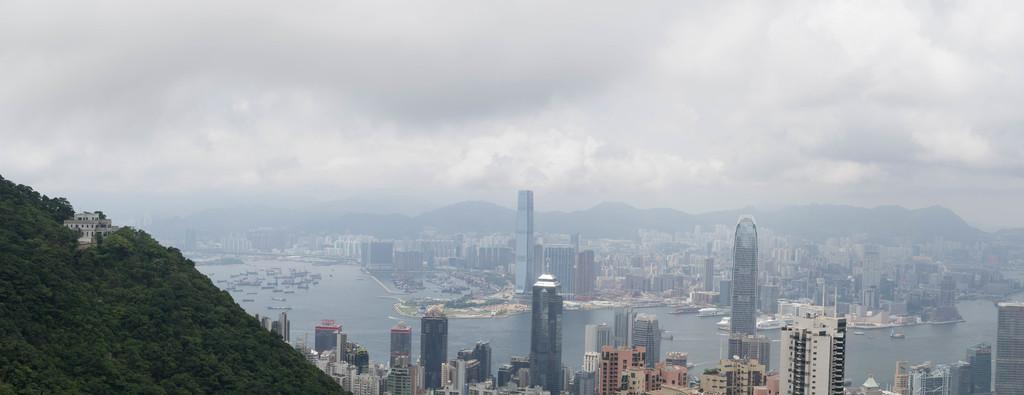What type of structures can be seen in the image? There are buildings in the image. What natural elements are present in the image? There are trees in the image. What is on the water in the image? There are boats on the water in the image. What else can be seen in the image besides buildings, trees, and boats? There are other objects in the image. What can be seen in the distance in the image? There are mountains visible in the background of the image, and the sky is also visible in the background. What type of cork is floating on the water in the image? There is no cork present in the image; it features boats on the water. How does the flight of birds affect the popcorn in the image? There is no popcorn or flight of birds present in the image. 